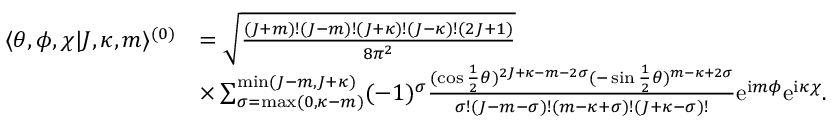<formula> <loc_0><loc_0><loc_500><loc_500>\begin{array} { r l } { \langle \theta , \phi , \chi | J , \kappa , m \rangle ^ { ( 0 ) } } & { = \sqrt { \frac { ( J + m ) ! ( J - m ) ! ( J + \kappa ) ! ( J - \kappa ) ! ( 2 J + 1 ) } { 8 \pi ^ { 2 } } } } \\ & { \times \sum _ { \sigma = \max ( 0 , \kappa - m ) } ^ { \min ( J - m , J + \kappa ) } ( - 1 ) ^ { \sigma } \frac { ( \cos \frac { 1 } { 2 } \theta ) ^ { 2 J + \kappa - m - 2 \sigma } ( - \sin \frac { 1 } { 2 } \theta ) ^ { m - \kappa + 2 \sigma } } { \sigma ! ( J - m - \sigma ) ! ( m - \kappa + \sigma ) ! ( J + \kappa - \sigma ) ! } e ^ { i m \phi } e ^ { i \kappa \chi } . } \end{array}</formula> 